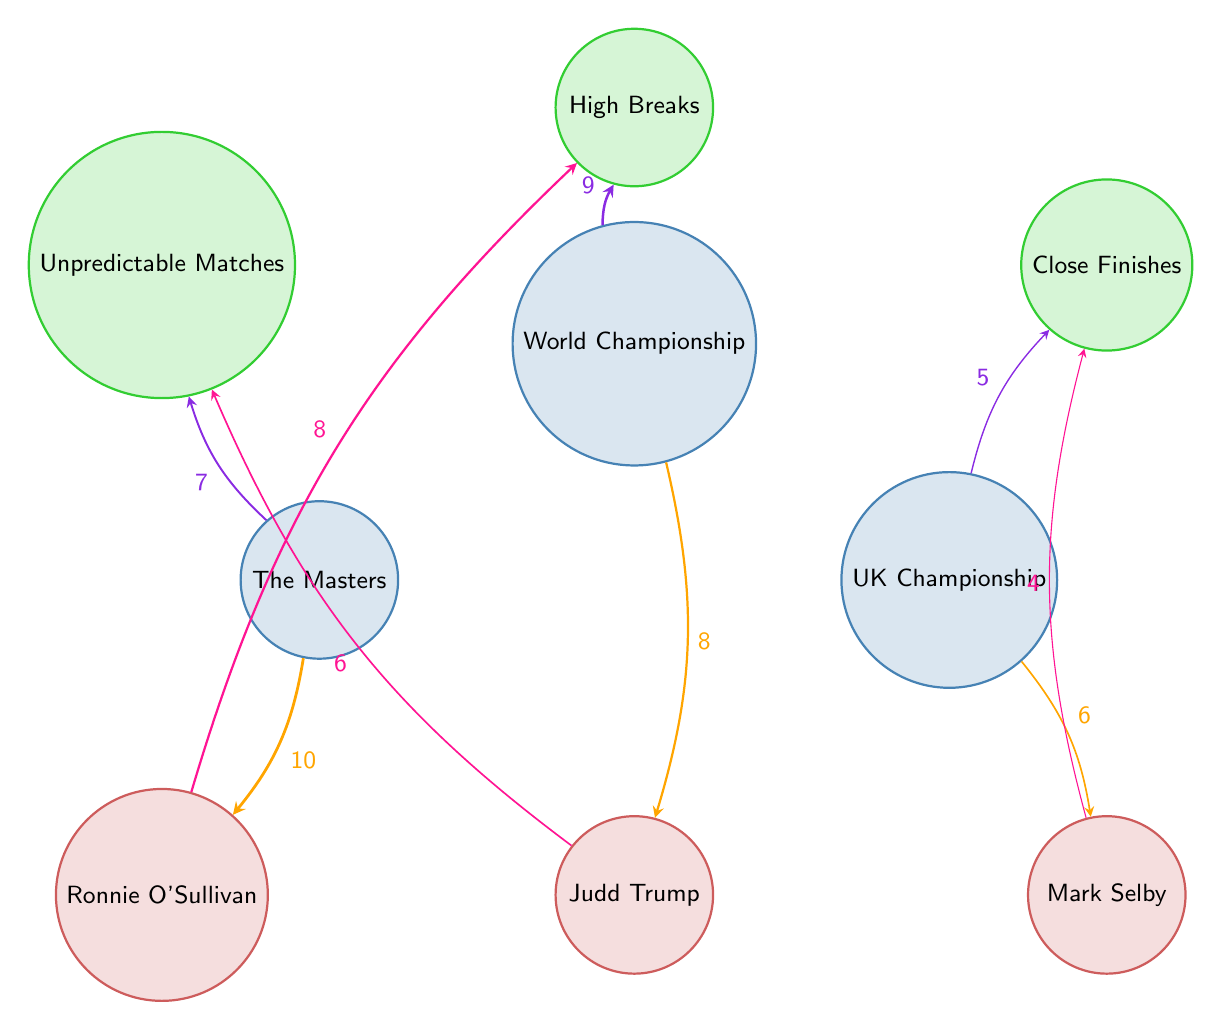What is the highest viewer interest value associated with Ronnie O'Sullivan? By examining the connections from the node representing Ronnie O'Sullivan, we can see a link to "High Breaks" with a value of 8. This is the highest viewer interest value connected to him.
Answer: 8 Which tournament is most associated with Unpredictable Matches? When we look at the link from "The Masters" to "Unpredictable Matches," there is a value of 7. This indicates its stronger association compared to the other tournaments.
Answer: The Masters How many players are shown in the diagram? The diagram has three specific nodes dedicated to players: Ronnie O'Sullivan, Judd Trump, and Mark Selby. Therefore, counting these nodes gives us a total of three players.
Answer: 3 What is the connection value between the World Championship and High Breaks? The connection from "World Championship" to "High Breaks" shows a value of 9. This is the specific number indicating viewer interest related to that relationship.
Answer: 9 What does the connection value between UK Championship and Close Finishes represent? The connection from "UK Championship" to "Close Finishes" has a value of 5, denoting the level of viewer interest in this match feature within that tournament.
Answer: 5 Which player has a direct association with Close Finishes? Mark Selby is directly connected to "Close Finishes" in the diagram, indicating he is associated with this match feature.
Answer: Mark Selby Which tournament has the lowest viewer interest value connected to a player? Looking at the connections associated with players, Mark Selby tied to "Close Finishes" has the lowest value at 4 compared to other player connections.
Answer: 4 How many connections are there in total in the diagram? By counting each of the lines drawn from the nodes (tournaments and players to features), there are nine connections in total within this diagram.
Answer: 9 What tournament is linked to the highest viewer interest value for a player? The Masters has the highest viewer interest value of 10 linked from it to Ronnie O'Sullivan, which is the maximum associated value for any tournament in this context.
Answer: The Masters 